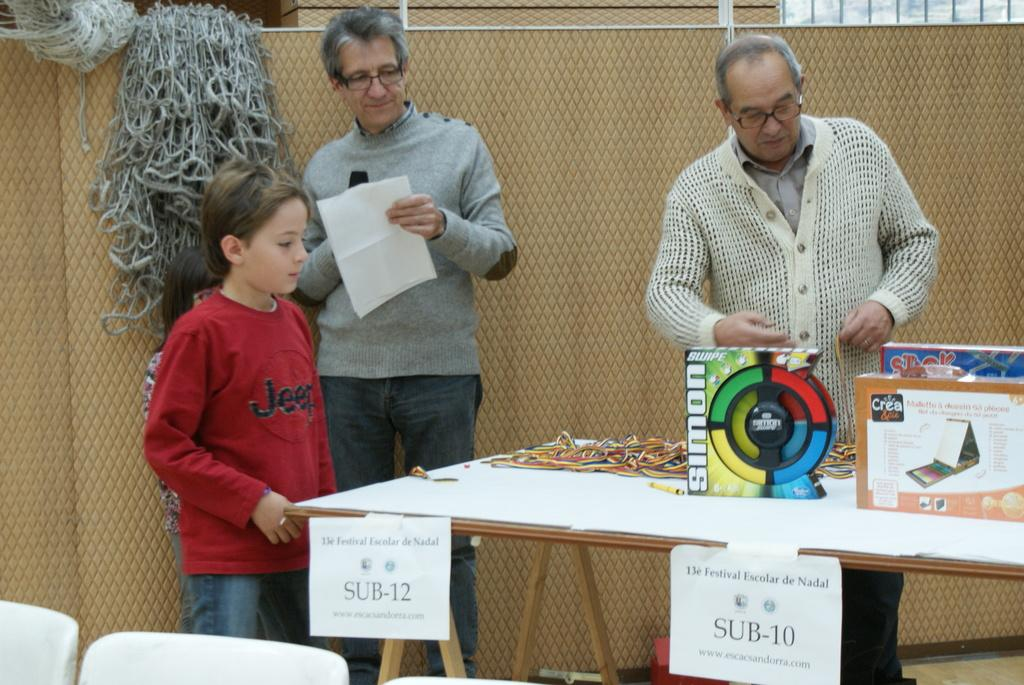How many people are in the image? There are two men and a boy in the image. What do both men have in common? Both men are wearing glasses. What is present in the image that could be used for holding or displaying items? There is a table in the image. What objects can be seen on the table? There are boxes on the table. What type of thought can be seen in the image? There is no thought visible in the image; it is a photograph of people and objects. 